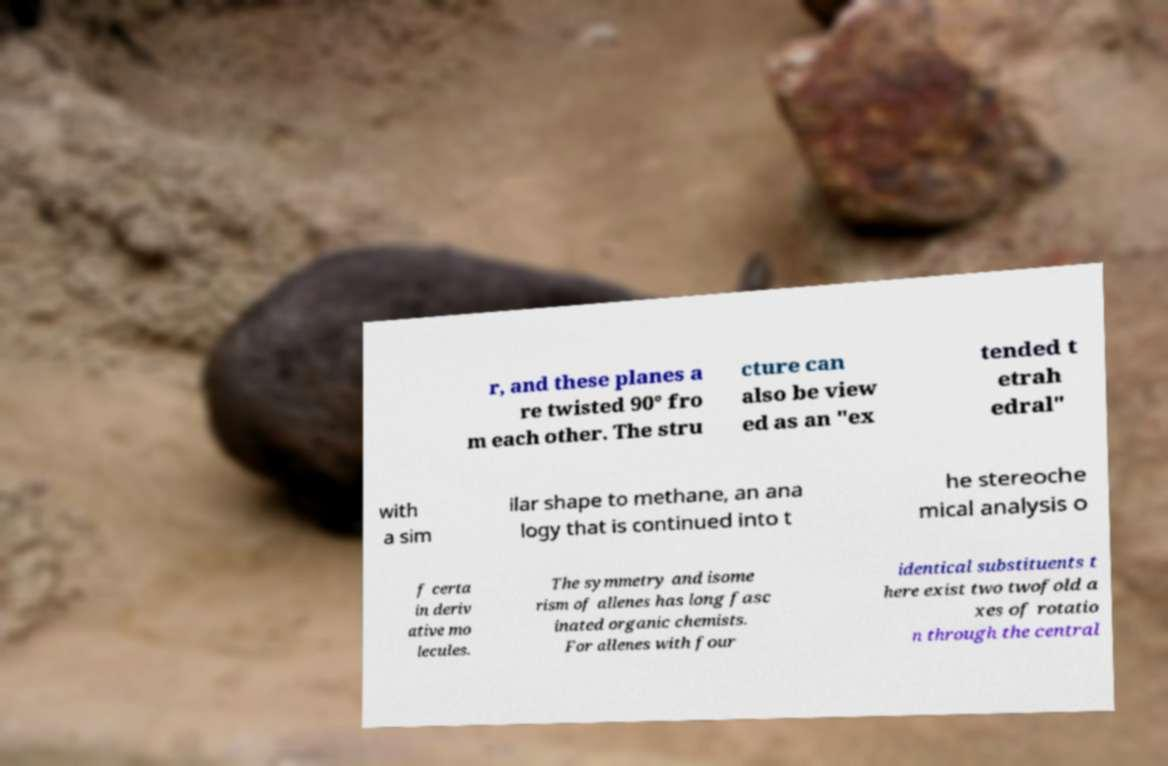Can you read and provide the text displayed in the image?This photo seems to have some interesting text. Can you extract and type it out for me? r, and these planes a re twisted 90° fro m each other. The stru cture can also be view ed as an "ex tended t etrah edral" with a sim ilar shape to methane, an ana logy that is continued into t he stereoche mical analysis o f certa in deriv ative mo lecules. The symmetry and isome rism of allenes has long fasc inated organic chemists. For allenes with four identical substituents t here exist two twofold a xes of rotatio n through the central 